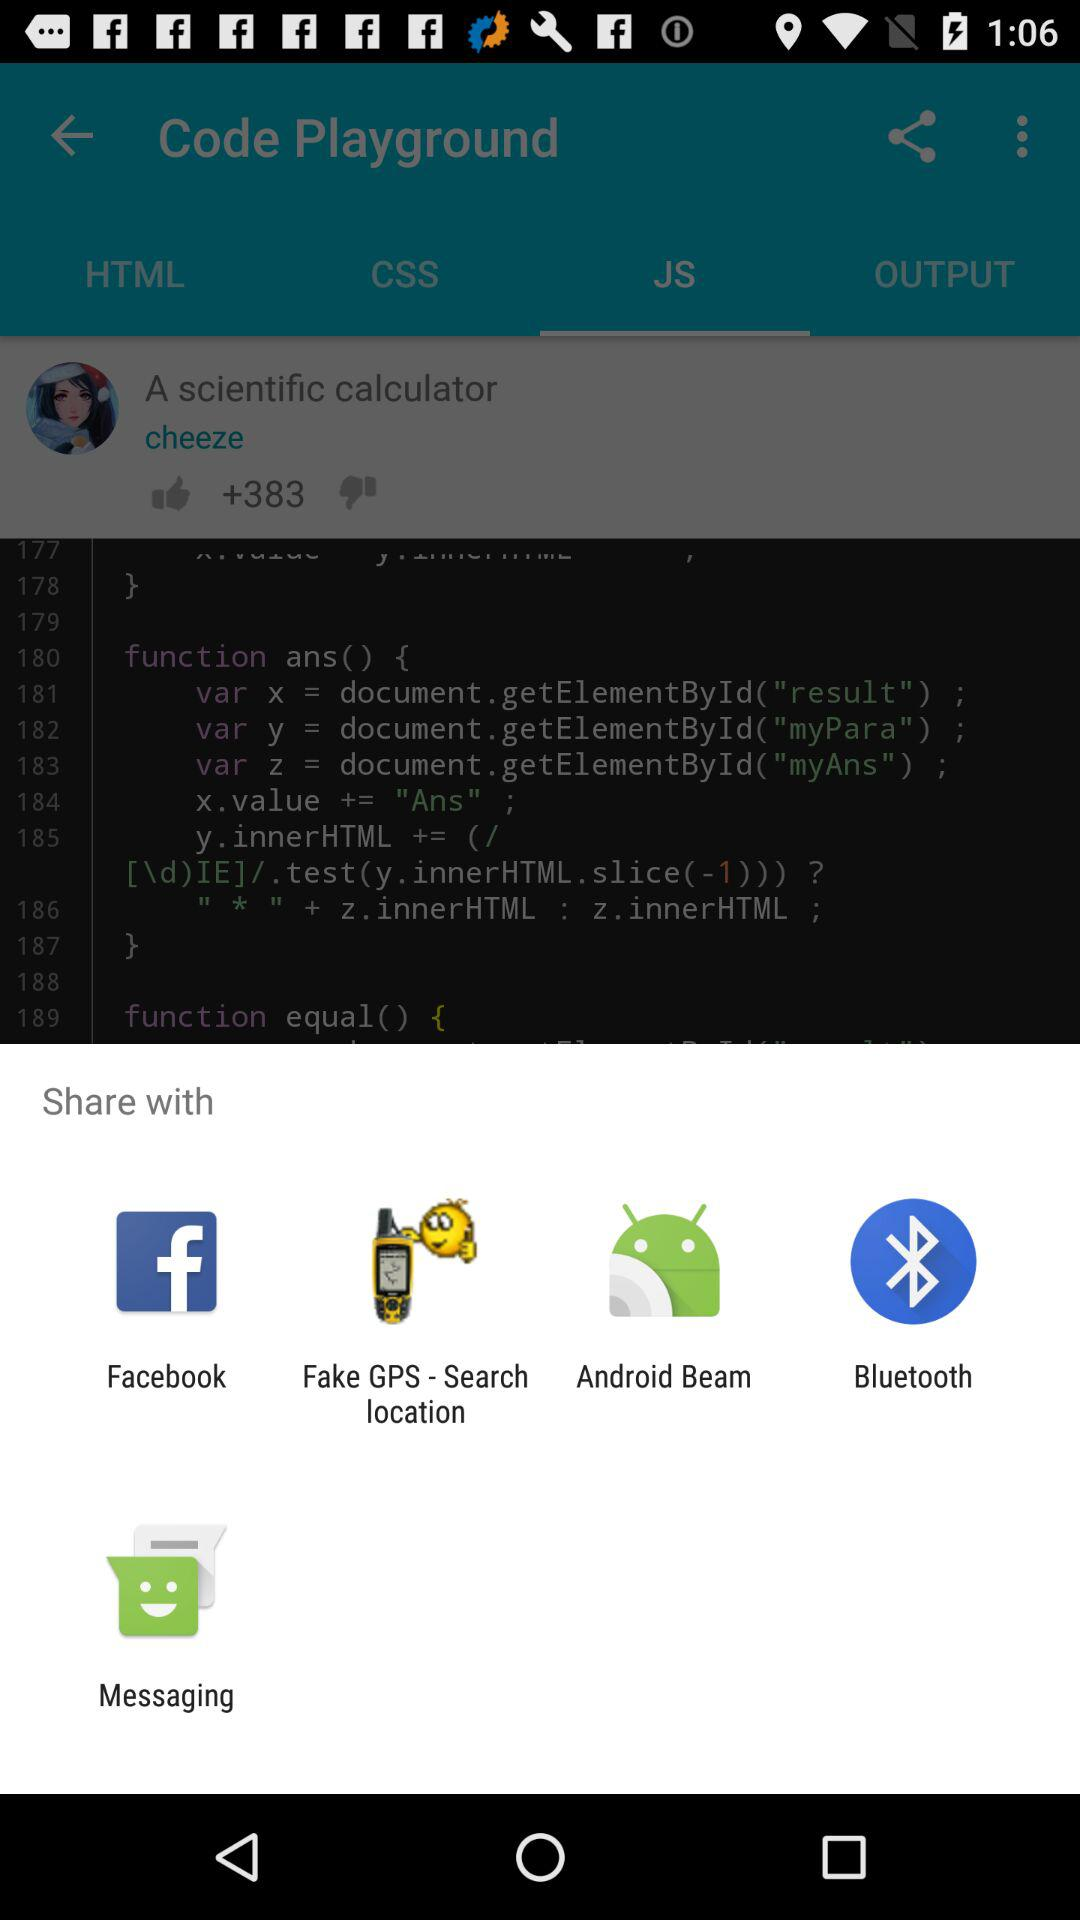Which applications are available for sharing?
When the provided information is insufficient, respond with <no answer>. <no answer> 